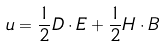<formula> <loc_0><loc_0><loc_500><loc_500>u = \frac { 1 } { 2 } D \cdot E + \frac { 1 } { 2 } H \cdot B</formula> 